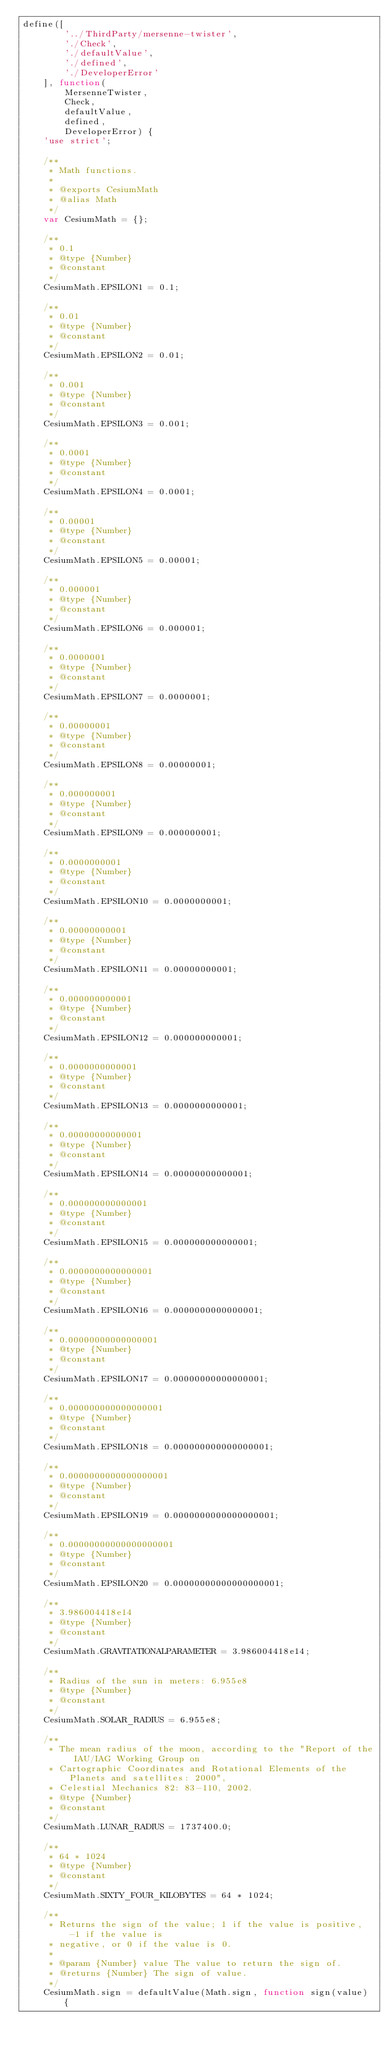<code> <loc_0><loc_0><loc_500><loc_500><_JavaScript_>define([
        '../ThirdParty/mersenne-twister',
        './Check',
        './defaultValue',
        './defined',
        './DeveloperError'
    ], function(
        MersenneTwister,
        Check,
        defaultValue,
        defined,
        DeveloperError) {
    'use strict';

    /**
     * Math functions.
     *
     * @exports CesiumMath
     * @alias Math
     */
    var CesiumMath = {};

    /**
     * 0.1
     * @type {Number}
     * @constant
     */
    CesiumMath.EPSILON1 = 0.1;

    /**
     * 0.01
     * @type {Number}
     * @constant
     */
    CesiumMath.EPSILON2 = 0.01;

    /**
     * 0.001
     * @type {Number}
     * @constant
     */
    CesiumMath.EPSILON3 = 0.001;

    /**
     * 0.0001
     * @type {Number}
     * @constant
     */
    CesiumMath.EPSILON4 = 0.0001;

    /**
     * 0.00001
     * @type {Number}
     * @constant
     */
    CesiumMath.EPSILON5 = 0.00001;

    /**
     * 0.000001
     * @type {Number}
     * @constant
     */
    CesiumMath.EPSILON6 = 0.000001;

    /**
     * 0.0000001
     * @type {Number}
     * @constant
     */
    CesiumMath.EPSILON7 = 0.0000001;

    /**
     * 0.00000001
     * @type {Number}
     * @constant
     */
    CesiumMath.EPSILON8 = 0.00000001;

    /**
     * 0.000000001
     * @type {Number}
     * @constant
     */
    CesiumMath.EPSILON9 = 0.000000001;

    /**
     * 0.0000000001
     * @type {Number}
     * @constant
     */
    CesiumMath.EPSILON10 = 0.0000000001;

    /**
     * 0.00000000001
     * @type {Number}
     * @constant
     */
    CesiumMath.EPSILON11 = 0.00000000001;

    /**
     * 0.000000000001
     * @type {Number}
     * @constant
     */
    CesiumMath.EPSILON12 = 0.000000000001;

    /**
     * 0.0000000000001
     * @type {Number}
     * @constant
     */
    CesiumMath.EPSILON13 = 0.0000000000001;

    /**
     * 0.00000000000001
     * @type {Number}
     * @constant
     */
    CesiumMath.EPSILON14 = 0.00000000000001;

    /**
     * 0.000000000000001
     * @type {Number}
     * @constant
     */
    CesiumMath.EPSILON15 = 0.000000000000001;

    /**
     * 0.0000000000000001
     * @type {Number}
     * @constant
     */
    CesiumMath.EPSILON16 = 0.0000000000000001;

    /**
     * 0.00000000000000001
     * @type {Number}
     * @constant
     */
    CesiumMath.EPSILON17 = 0.00000000000000001;

    /**
     * 0.000000000000000001
     * @type {Number}
     * @constant
     */
    CesiumMath.EPSILON18 = 0.000000000000000001;

    /**
     * 0.0000000000000000001
     * @type {Number}
     * @constant
     */
    CesiumMath.EPSILON19 = 0.0000000000000000001;

    /**
     * 0.00000000000000000001
     * @type {Number}
     * @constant
     */
    CesiumMath.EPSILON20 = 0.00000000000000000001;

    /**
     * 3.986004418e14
     * @type {Number}
     * @constant
     */
    CesiumMath.GRAVITATIONALPARAMETER = 3.986004418e14;

    /**
     * Radius of the sun in meters: 6.955e8
     * @type {Number}
     * @constant
     */
    CesiumMath.SOLAR_RADIUS = 6.955e8;

    /**
     * The mean radius of the moon, according to the "Report of the IAU/IAG Working Group on
     * Cartographic Coordinates and Rotational Elements of the Planets and satellites: 2000",
     * Celestial Mechanics 82: 83-110, 2002.
     * @type {Number}
     * @constant
     */
    CesiumMath.LUNAR_RADIUS = 1737400.0;

    /**
     * 64 * 1024
     * @type {Number}
     * @constant
     */
    CesiumMath.SIXTY_FOUR_KILOBYTES = 64 * 1024;

    /**
     * Returns the sign of the value; 1 if the value is positive, -1 if the value is
     * negative, or 0 if the value is 0.
     *
     * @param {Number} value The value to return the sign of.
     * @returns {Number} The sign of value.
     */
    CesiumMath.sign = defaultValue(Math.sign, function sign(value) {</code> 